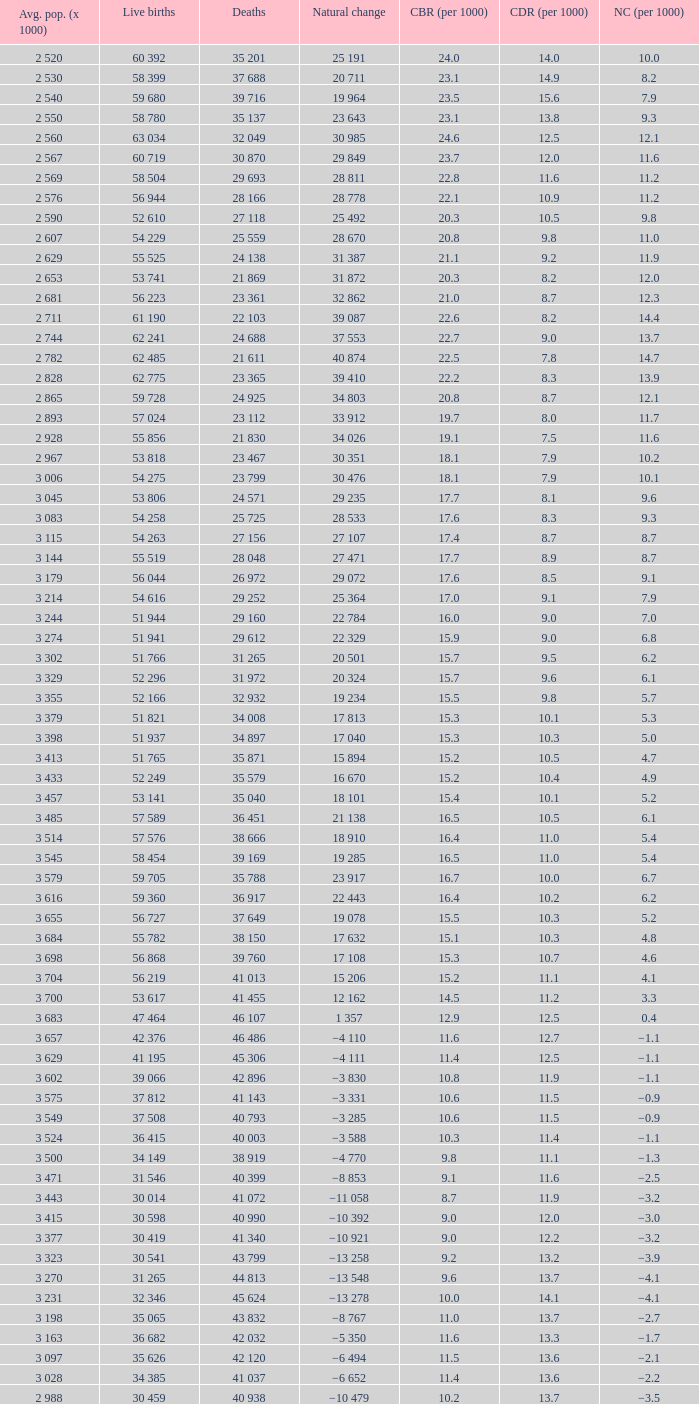Could you help me parse every detail presented in this table? {'header': ['Avg. pop. (x 1000)', 'Live births', 'Deaths', 'Natural change', 'CBR (per 1000)', 'CDR (per 1000)', 'NC (per 1000)'], 'rows': [['2 520', '60 392', '35 201', '25 191', '24.0', '14.0', '10.0'], ['2 530', '58 399', '37 688', '20 711', '23.1', '14.9', '8.2'], ['2 540', '59 680', '39 716', '19 964', '23.5', '15.6', '7.9'], ['2 550', '58 780', '35 137', '23 643', '23.1', '13.8', '9.3'], ['2 560', '63 034', '32 049', '30 985', '24.6', '12.5', '12.1'], ['2 567', '60 719', '30 870', '29 849', '23.7', '12.0', '11.6'], ['2 569', '58 504', '29 693', '28 811', '22.8', '11.6', '11.2'], ['2 576', '56 944', '28 166', '28 778', '22.1', '10.9', '11.2'], ['2 590', '52 610', '27 118', '25 492', '20.3', '10.5', '9.8'], ['2 607', '54 229', '25 559', '28 670', '20.8', '9.8', '11.0'], ['2 629', '55 525', '24 138', '31 387', '21.1', '9.2', '11.9'], ['2 653', '53 741', '21 869', '31 872', '20.3', '8.2', '12.0'], ['2 681', '56 223', '23 361', '32 862', '21.0', '8.7', '12.3'], ['2 711', '61 190', '22 103', '39 087', '22.6', '8.2', '14.4'], ['2 744', '62 241', '24 688', '37 553', '22.7', '9.0', '13.7'], ['2 782', '62 485', '21 611', '40 874', '22.5', '7.8', '14.7'], ['2 828', '62 775', '23 365', '39 410', '22.2', '8.3', '13.9'], ['2 865', '59 728', '24 925', '34 803', '20.8', '8.7', '12.1'], ['2 893', '57 024', '23 112', '33 912', '19.7', '8.0', '11.7'], ['2 928', '55 856', '21 830', '34 026', '19.1', '7.5', '11.6'], ['2 967', '53 818', '23 467', '30 351', '18.1', '7.9', '10.2'], ['3 006', '54 275', '23 799', '30 476', '18.1', '7.9', '10.1'], ['3 045', '53 806', '24 571', '29 235', '17.7', '8.1', '9.6'], ['3 083', '54 258', '25 725', '28 533', '17.6', '8.3', '9.3'], ['3 115', '54 263', '27 156', '27 107', '17.4', '8.7', '8.7'], ['3 144', '55 519', '28 048', '27 471', '17.7', '8.9', '8.7'], ['3 179', '56 044', '26 972', '29 072', '17.6', '8.5', '9.1'], ['3 214', '54 616', '29 252', '25 364', '17.0', '9.1', '7.9'], ['3 244', '51 944', '29 160', '22 784', '16.0', '9.0', '7.0'], ['3 274', '51 941', '29 612', '22 329', '15.9', '9.0', '6.8'], ['3 302', '51 766', '31 265', '20 501', '15.7', '9.5', '6.2'], ['3 329', '52 296', '31 972', '20 324', '15.7', '9.6', '6.1'], ['3 355', '52 166', '32 932', '19 234', '15.5', '9.8', '5.7'], ['3 379', '51 821', '34 008', '17 813', '15.3', '10.1', '5.3'], ['3 398', '51 937', '34 897', '17 040', '15.3', '10.3', '5.0'], ['3 413', '51 765', '35 871', '15 894', '15.2', '10.5', '4.7'], ['3 433', '52 249', '35 579', '16 670', '15.2', '10.4', '4.9'], ['3 457', '53 141', '35 040', '18 101', '15.4', '10.1', '5.2'], ['3 485', '57 589', '36 451', '21 138', '16.5', '10.5', '6.1'], ['3 514', '57 576', '38 666', '18 910', '16.4', '11.0', '5.4'], ['3 545', '58 454', '39 169', '19 285', '16.5', '11.0', '5.4'], ['3 579', '59 705', '35 788', '23 917', '16.7', '10.0', '6.7'], ['3 616', '59 360', '36 917', '22 443', '16.4', '10.2', '6.2'], ['3 655', '56 727', '37 649', '19 078', '15.5', '10.3', '5.2'], ['3 684', '55 782', '38 150', '17 632', '15.1', '10.3', '4.8'], ['3 698', '56 868', '39 760', '17 108', '15.3', '10.7', '4.6'], ['3 704', '56 219', '41 013', '15 206', '15.2', '11.1', '4.1'], ['3 700', '53 617', '41 455', '12 162', '14.5', '11.2', '3.3'], ['3 683', '47 464', '46 107', '1 357', '12.9', '12.5', '0.4'], ['3 657', '42 376', '46 486', '−4 110', '11.6', '12.7', '−1.1'], ['3 629', '41 195', '45 306', '−4 111', '11.4', '12.5', '−1.1'], ['3 602', '39 066', '42 896', '−3 830', '10.8', '11.9', '−1.1'], ['3 575', '37 812', '41 143', '−3 331', '10.6', '11.5', '−0.9'], ['3 549', '37 508', '40 793', '−3 285', '10.6', '11.5', '−0.9'], ['3 524', '36 415', '40 003', '−3 588', '10.3', '11.4', '−1.1'], ['3 500', '34 149', '38 919', '−4 770', '9.8', '11.1', '−1.3'], ['3 471', '31 546', '40 399', '−8 853', '9.1', '11.6', '−2.5'], ['3 443', '30 014', '41 072', '−11 058', '8.7', '11.9', '−3.2'], ['3 415', '30 598', '40 990', '−10 392', '9.0', '12.0', '−3.0'], ['3 377', '30 419', '41 340', '−10 921', '9.0', '12.2', '−3.2'], ['3 323', '30 541', '43 799', '−13 258', '9.2', '13.2', '−3.9'], ['3 270', '31 265', '44 813', '−13 548', '9.6', '13.7', '−4.1'], ['3 231', '32 346', '45 624', '−13 278', '10.0', '14.1', '−4.1'], ['3 198', '35 065', '43 832', '−8 767', '11.0', '13.7', '−2.7'], ['3 163', '36 682', '42 032', '−5 350', '11.6', '13.3', '−1.7'], ['3 097', '35 626', '42 120', '−6 494', '11.5', '13.6', '−2.1'], ['3 028', '34 385', '41 037', '−6 652', '11.4', '13.6', '−2.2'], ['2 988', '30 459', '40 938', '−10 479', '10.2', '13.7', '−3.5']]} Which Natural change has a Crude death rate (per 1000) larger than 9, and Deaths of 40 399? −8 853. 